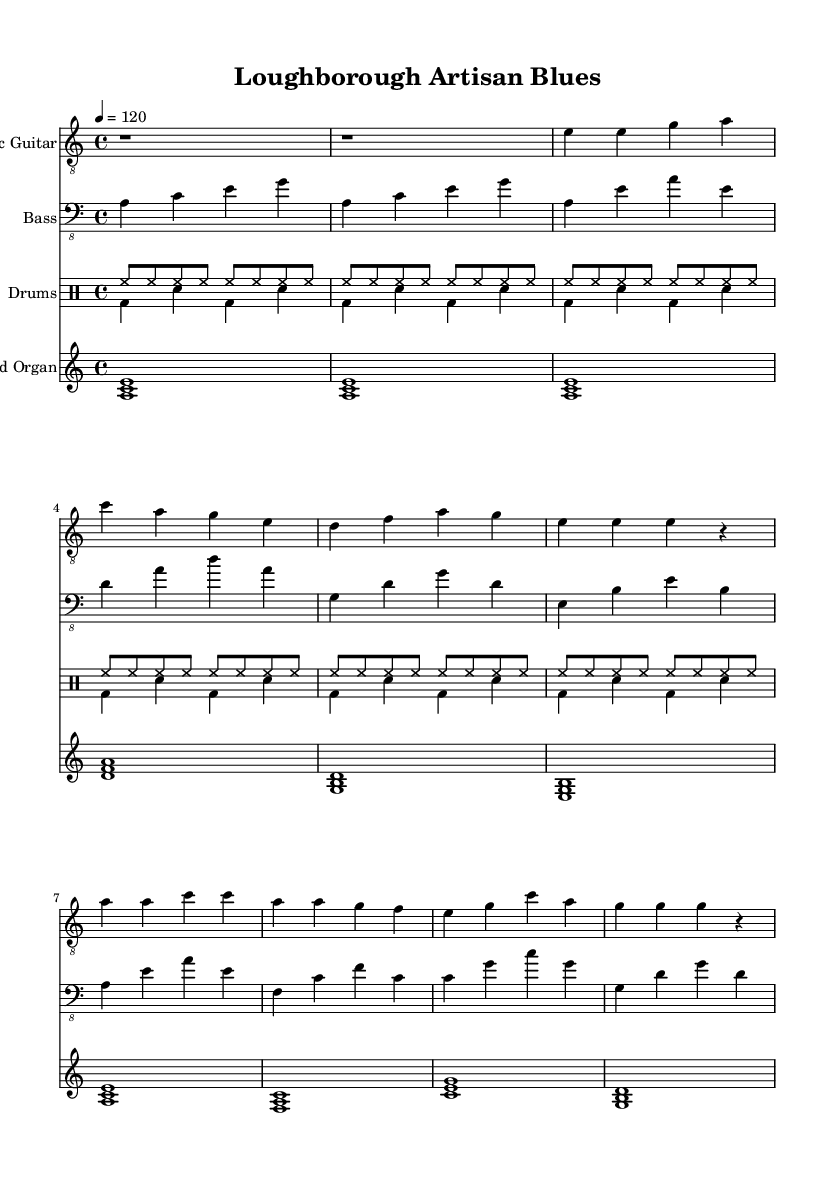What is the key signature of this music? The key signature is A minor, which is indicated by the absence of sharps or flats on the staff.
Answer: A minor What is the time signature of this music? The time signature is 4/4, which means there are four beats in each measure and the quarter note gets one beat.
Answer: 4/4 What is the tempo marking of this piece? The tempo marking is given as a metronome marking of 120 beats per minute, indicated by "4 = 120."
Answer: 120 How many measures are in the chorus section? The chorus section consists of four measures, as indicated by the grouping in the sheet music.
Answer: 4 What instruments are used in this piece? The instruments used in this piece are electric guitar, bass, drums, and Hammond organ, as shown in the staff names.
Answer: Electric Guitar, Bass, Drums, Hammond Organ What is the main chord progression in the chorus? The main chord progression in the chorus is A, C, A, G, E, G, C, A, as indicated by the notes played in the treble staff.
Answer: A, C, A, G, E, G, C, A Is this piece considered to be in a minor tonality? Yes, the piece is in a minor tonality since it is based on the A minor key signature, which suggests a darker mood typical of electric blues.
Answer: Yes 